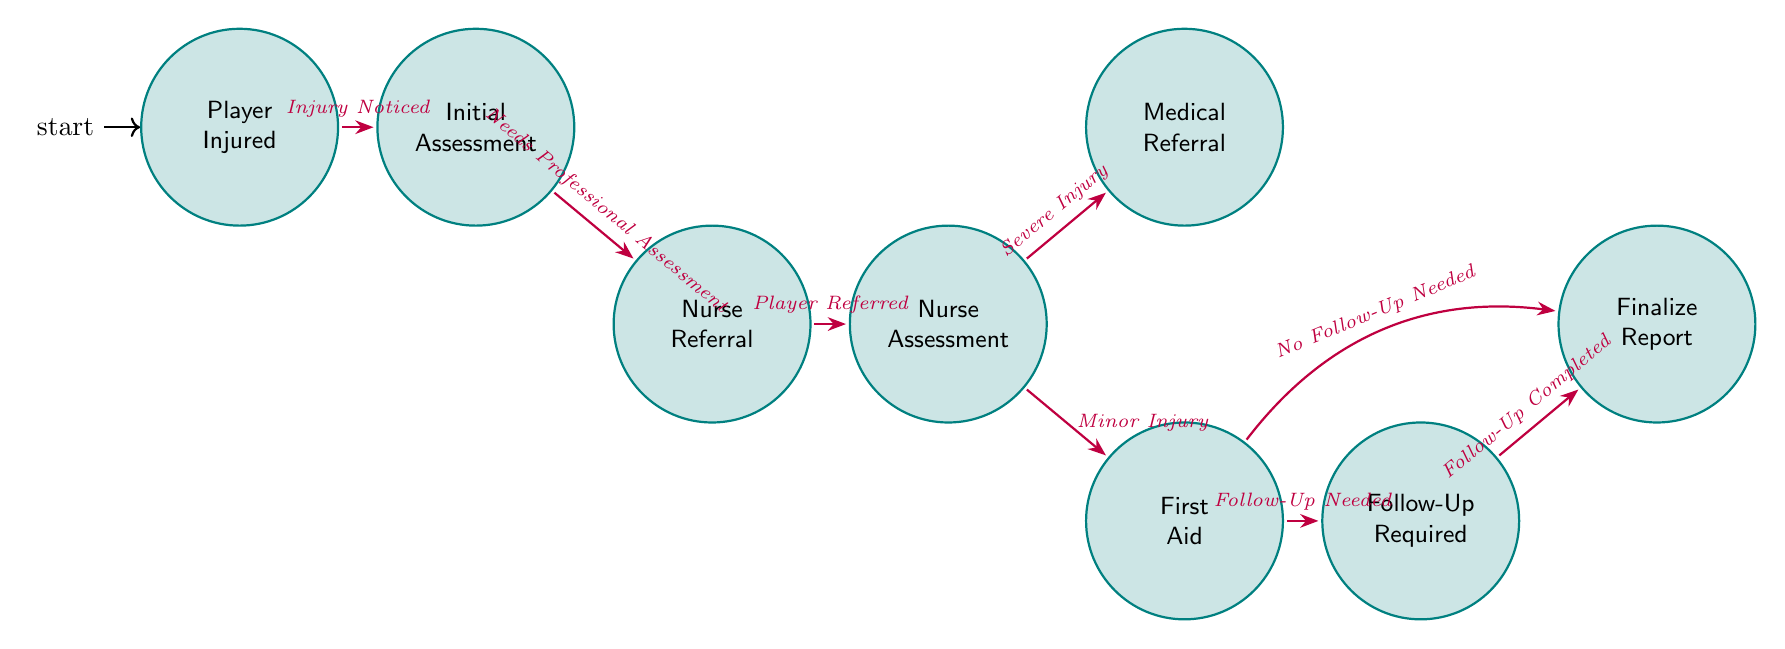What is the first state after a player is injured? The first state that follows after a player is injured is "Initial Assessment," as indicated by the transition starting from "Player Injured."
Answer: Initial Assessment How many nodes are there in the diagram? The diagram has eight states or nodes, corresponding to different stages in the injury incident reporting process.
Answer: Eight What trigger leads from "Initial Assessment" to "Nurse Referral"? The trigger that leads to "Nurse Referral" from "Initial Assessment" is "Needs Professional Assessment." This indicates that the coach determines a need for the nurse's evaluation.
Answer: Needs Professional Assessment If an injury is assessed as minor, which state does it transition to next? If an injury is classified as minor during the "Nurse Assessment," the next state it transitions to is "First Aid." This is specifically denoted by the relevant trigger for minor injuries.
Answer: First Aid What is the last state in the diagram that concludes the process? The last state in the diagram is "Finalize Report," which is where the incident report is completed and filed.
Answer: Finalize Report How many transitions are there in the diagram? There are eight transitions in total that connect the states, indicating the flow of the injury reporting process.
Answer: Eight Which state requires follow-up care guidance? The state that provides guidance on follow-up care is "Follow-Up Required." It occurs after first aid is given when follow-up care is deemed necessary.
Answer: Follow-Up Required What happens if no follow-up is needed after First Aid? If no follow-up is needed after "First Aid," the process transitions directly to "Finalize Report," completing the reporting process without additional follow-up steps.
Answer: Finalize Report 